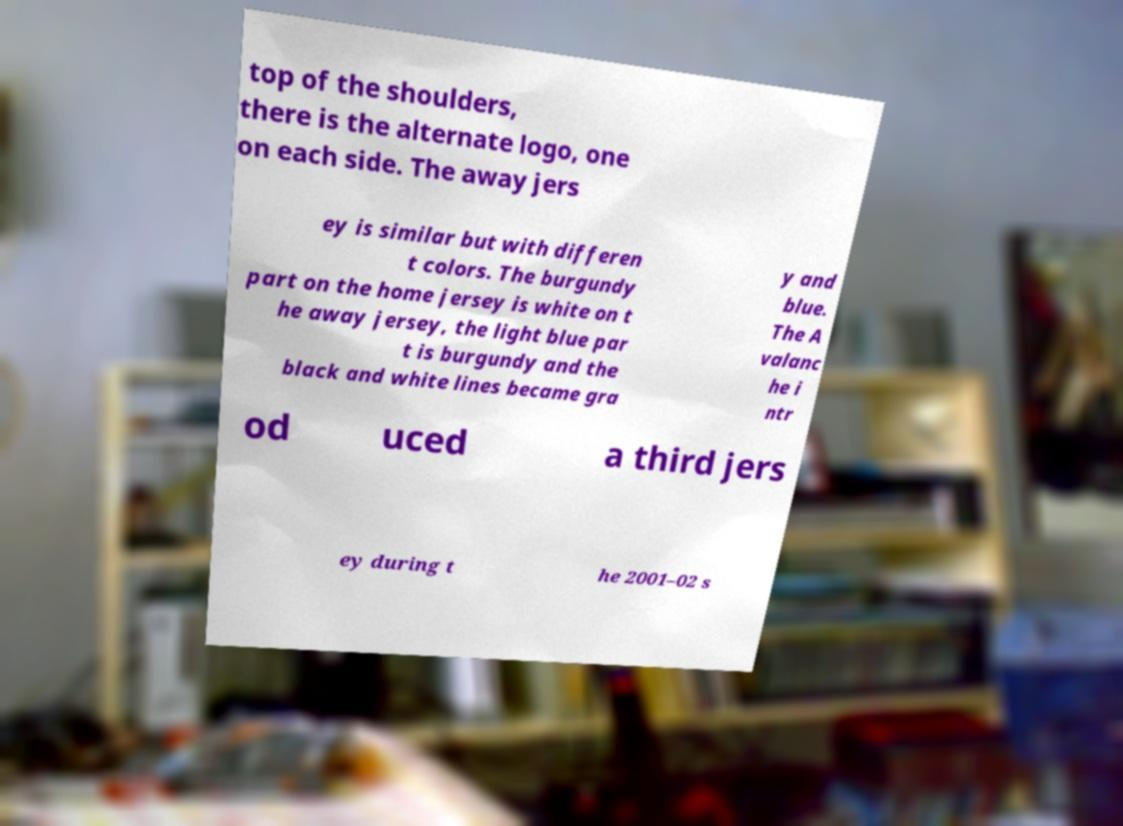Please read and relay the text visible in this image. What does it say? top of the shoulders, there is the alternate logo, one on each side. The away jers ey is similar but with differen t colors. The burgundy part on the home jersey is white on t he away jersey, the light blue par t is burgundy and the black and white lines became gra y and blue. The A valanc he i ntr od uced a third jers ey during t he 2001–02 s 